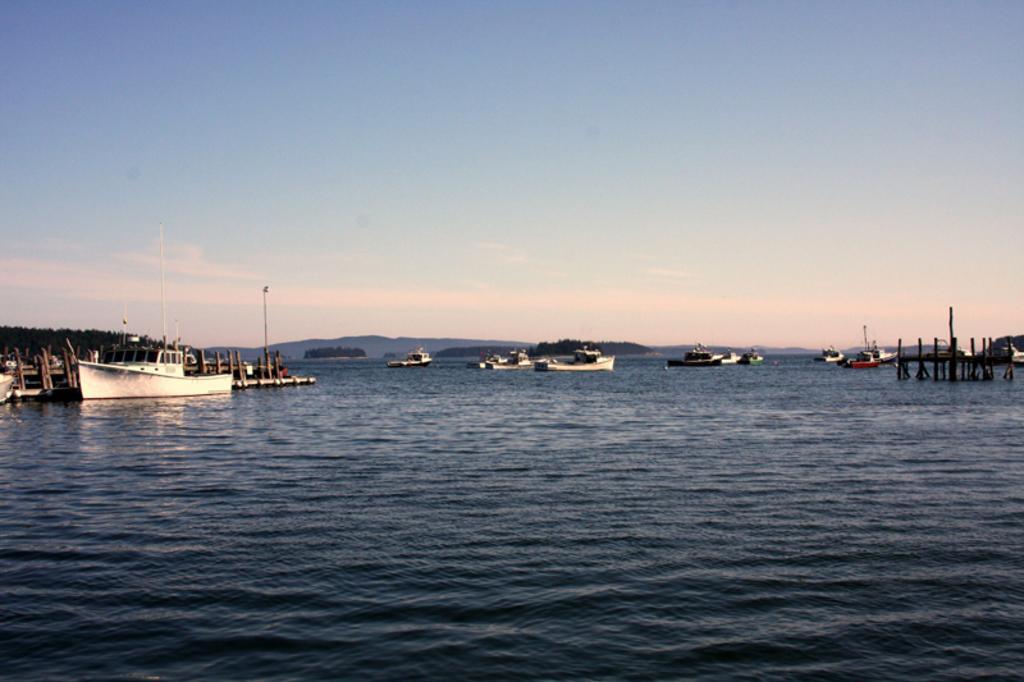Can you describe this image briefly? In this image we can see some ships on the ocean, there are poles, trees, wooden poles, also we can see the mountains, and the sky. 